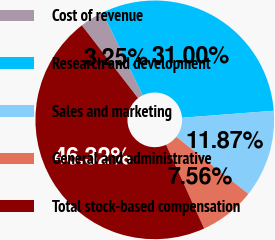<chart> <loc_0><loc_0><loc_500><loc_500><pie_chart><fcel>Cost of revenue<fcel>Research and development<fcel>Sales and marketing<fcel>General and administrative<fcel>Total stock-based compensation<nl><fcel>3.25%<fcel>31.0%<fcel>11.87%<fcel>7.56%<fcel>46.32%<nl></chart> 